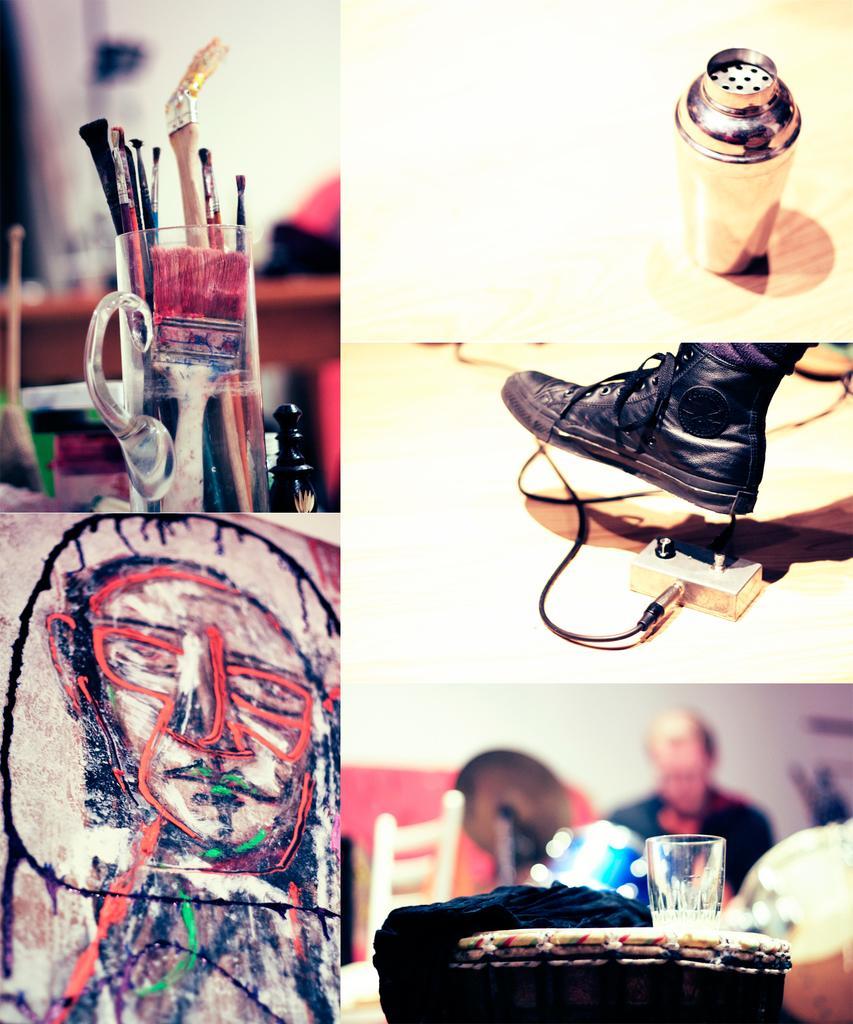Please provide a concise description of this image. In this image we can see one bottle is on the surface. Some objects are there on the table. One big wall is painted and jug containing some paint brushes. Some objects are on the surface. There is one glass, cloth on the table. One person is sitting and playing musical instrument, some objects are there on the right side of the person. 